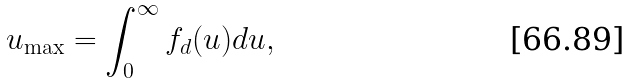<formula> <loc_0><loc_0><loc_500><loc_500>u _ { \max } = \int _ { 0 } ^ { \infty } f _ { d } ( u ) d u ,</formula> 